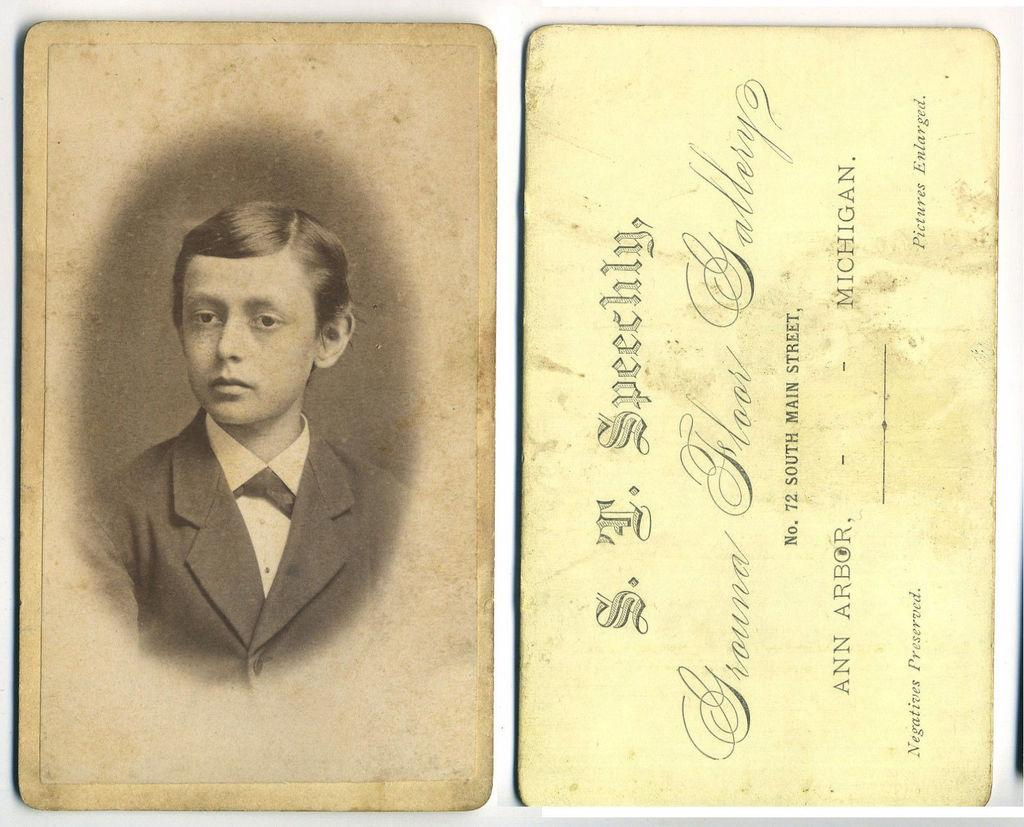What objects are present in the image? There are cards in the image. What is depicted on the cards? The cards contain depictions of a person. Are there any words or letters on the cards? Yes, the cards have some text on them. What type of bottle is being used to propose to the person on the card? There is no bottle present in the image, and no proposal is depicted. 